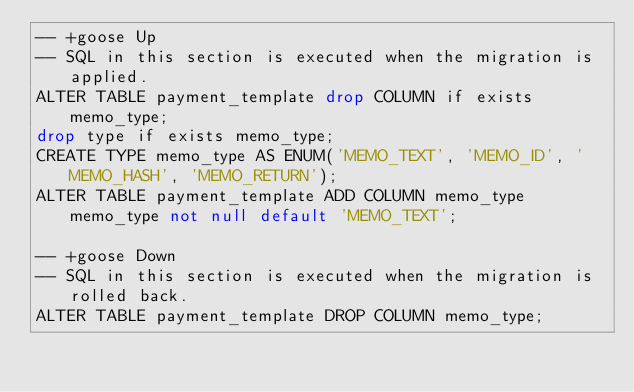<code> <loc_0><loc_0><loc_500><loc_500><_SQL_>-- +goose Up
-- SQL in this section is executed when the migration is applied.
ALTER TABLE payment_template drop COLUMN if exists memo_type;
drop type if exists memo_type;
CREATE TYPE memo_type AS ENUM('MEMO_TEXT', 'MEMO_ID', 'MEMO_HASH', 'MEMO_RETURN');
ALTER TABLE payment_template ADD COLUMN memo_type memo_type not null default 'MEMO_TEXT';

-- +goose Down
-- SQL in this section is executed when the migration is rolled back.
ALTER TABLE payment_template DROP COLUMN memo_type;</code> 